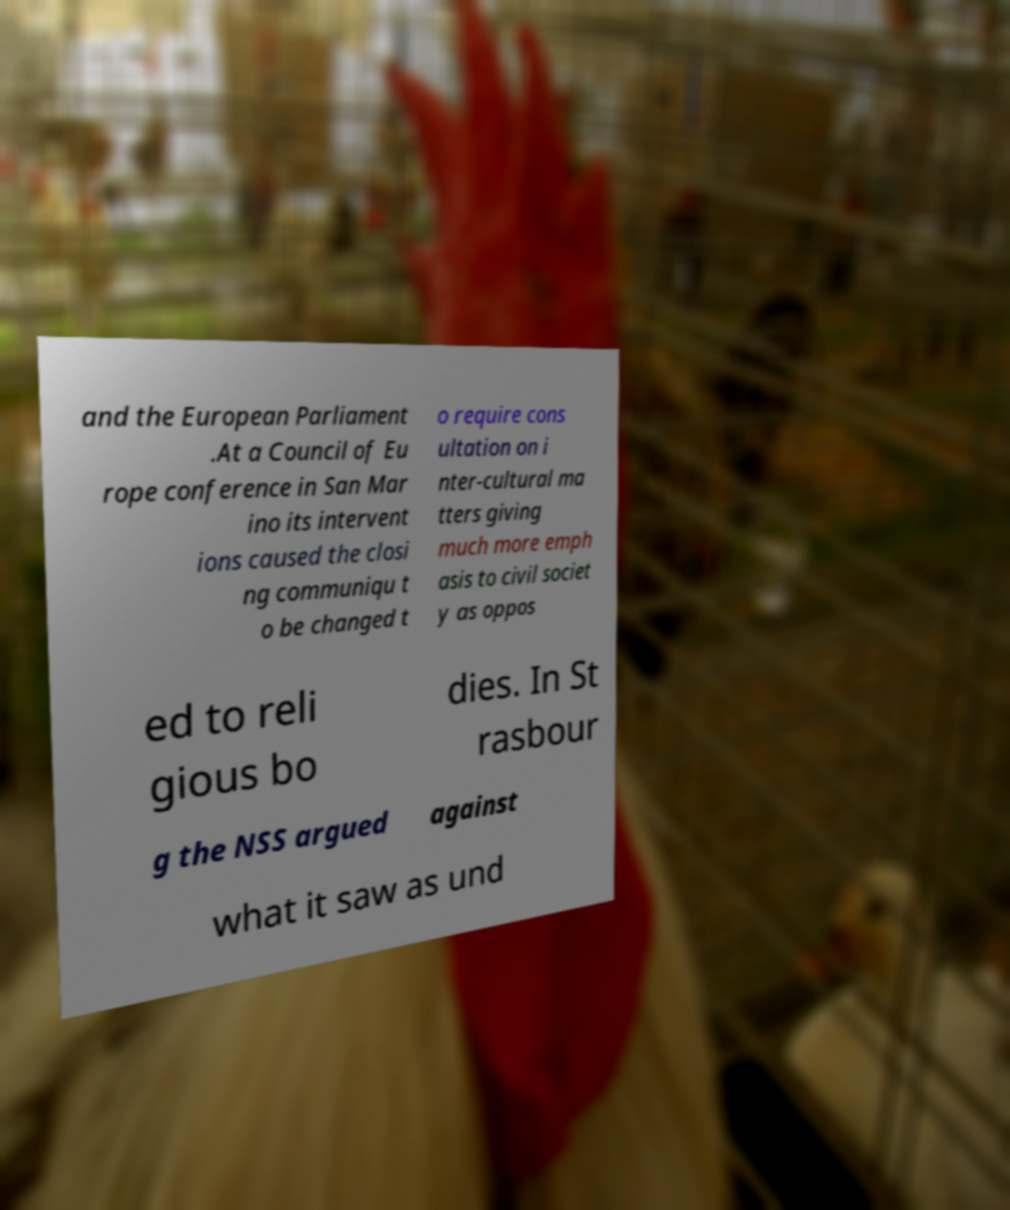Can you accurately transcribe the text from the provided image for me? and the European Parliament .At a Council of Eu rope conference in San Mar ino its intervent ions caused the closi ng communiqu t o be changed t o require cons ultation on i nter-cultural ma tters giving much more emph asis to civil societ y as oppos ed to reli gious bo dies. In St rasbour g the NSS argued against what it saw as und 